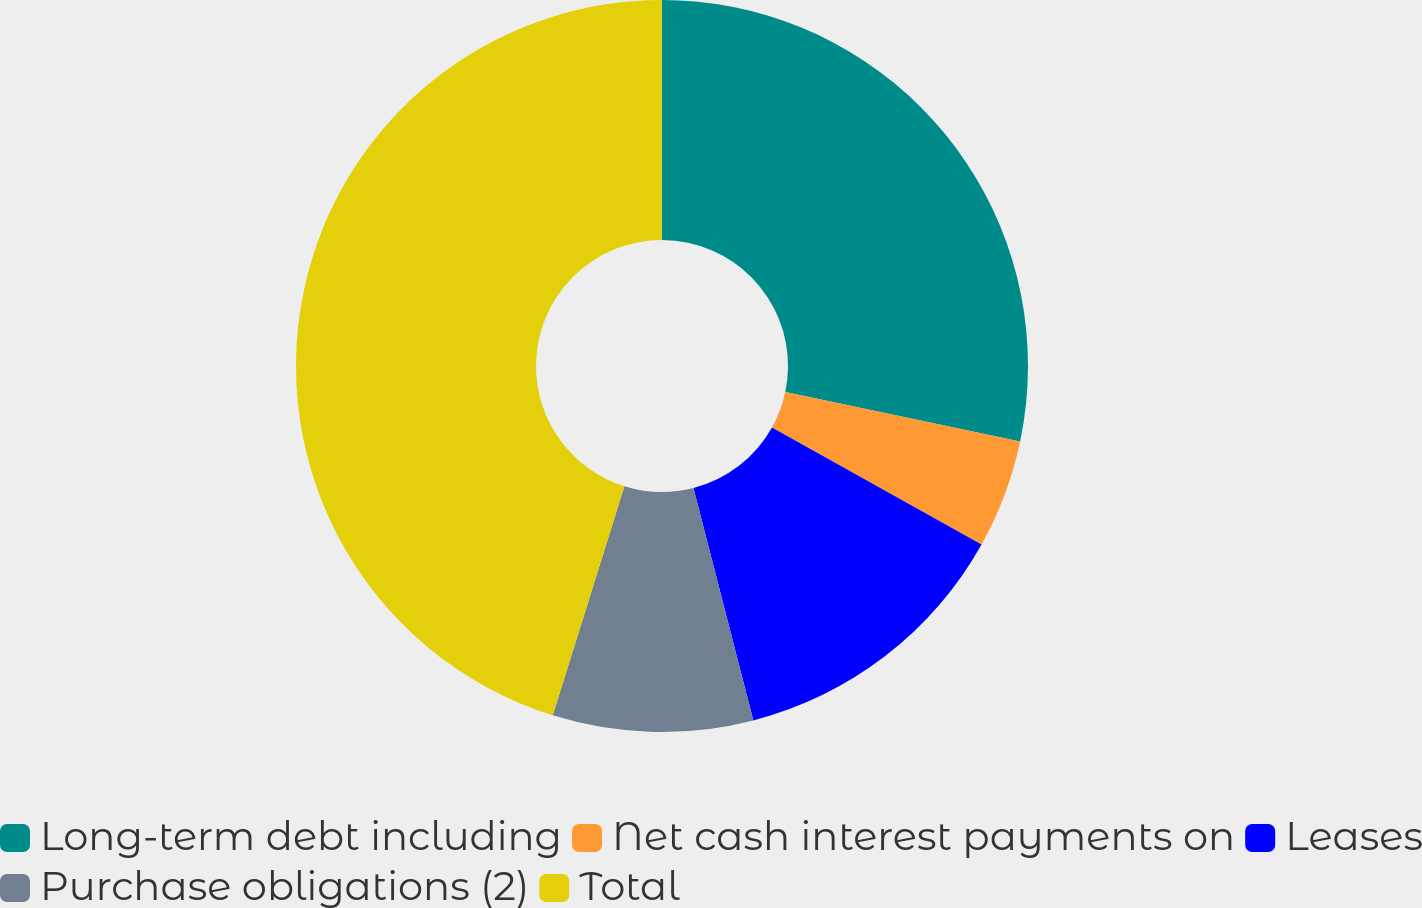Convert chart to OTSL. <chart><loc_0><loc_0><loc_500><loc_500><pie_chart><fcel>Long-term debt including<fcel>Net cash interest payments on<fcel>Leases<fcel>Purchase obligations (2)<fcel>Total<nl><fcel>28.31%<fcel>4.8%<fcel>12.88%<fcel>8.84%<fcel>45.18%<nl></chart> 